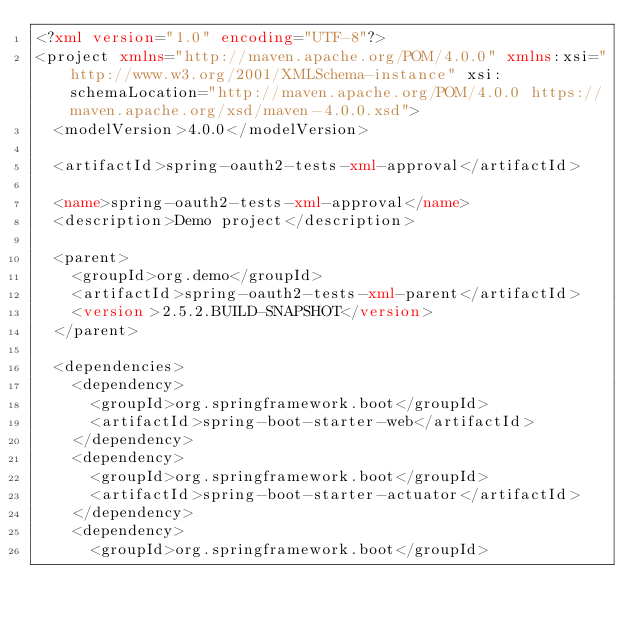<code> <loc_0><loc_0><loc_500><loc_500><_XML_><?xml version="1.0" encoding="UTF-8"?>
<project xmlns="http://maven.apache.org/POM/4.0.0" xmlns:xsi="http://www.w3.org/2001/XMLSchema-instance" xsi:schemaLocation="http://maven.apache.org/POM/4.0.0 https://maven.apache.org/xsd/maven-4.0.0.xsd">
	<modelVersion>4.0.0</modelVersion>

	<artifactId>spring-oauth2-tests-xml-approval</artifactId>

	<name>spring-oauth2-tests-xml-approval</name>
	<description>Demo project</description>

	<parent>
		<groupId>org.demo</groupId>
		<artifactId>spring-oauth2-tests-xml-parent</artifactId>
		<version>2.5.2.BUILD-SNAPSHOT</version>
	</parent>

	<dependencies>
		<dependency>
			<groupId>org.springframework.boot</groupId>
			<artifactId>spring-boot-starter-web</artifactId>
		</dependency>
		<dependency>
			<groupId>org.springframework.boot</groupId>
			<artifactId>spring-boot-starter-actuator</artifactId>
		</dependency>
		<dependency>
			<groupId>org.springframework.boot</groupId></code> 